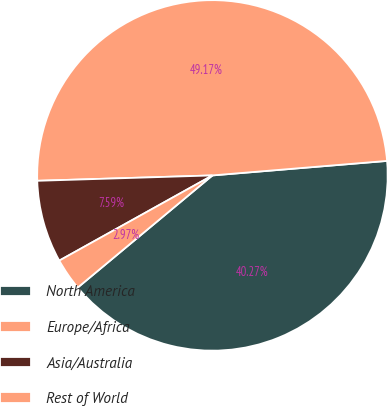Convert chart. <chart><loc_0><loc_0><loc_500><loc_500><pie_chart><fcel>North America<fcel>Europe/Africa<fcel>Asia/Australia<fcel>Rest of World<nl><fcel>40.27%<fcel>49.17%<fcel>7.59%<fcel>2.97%<nl></chart> 